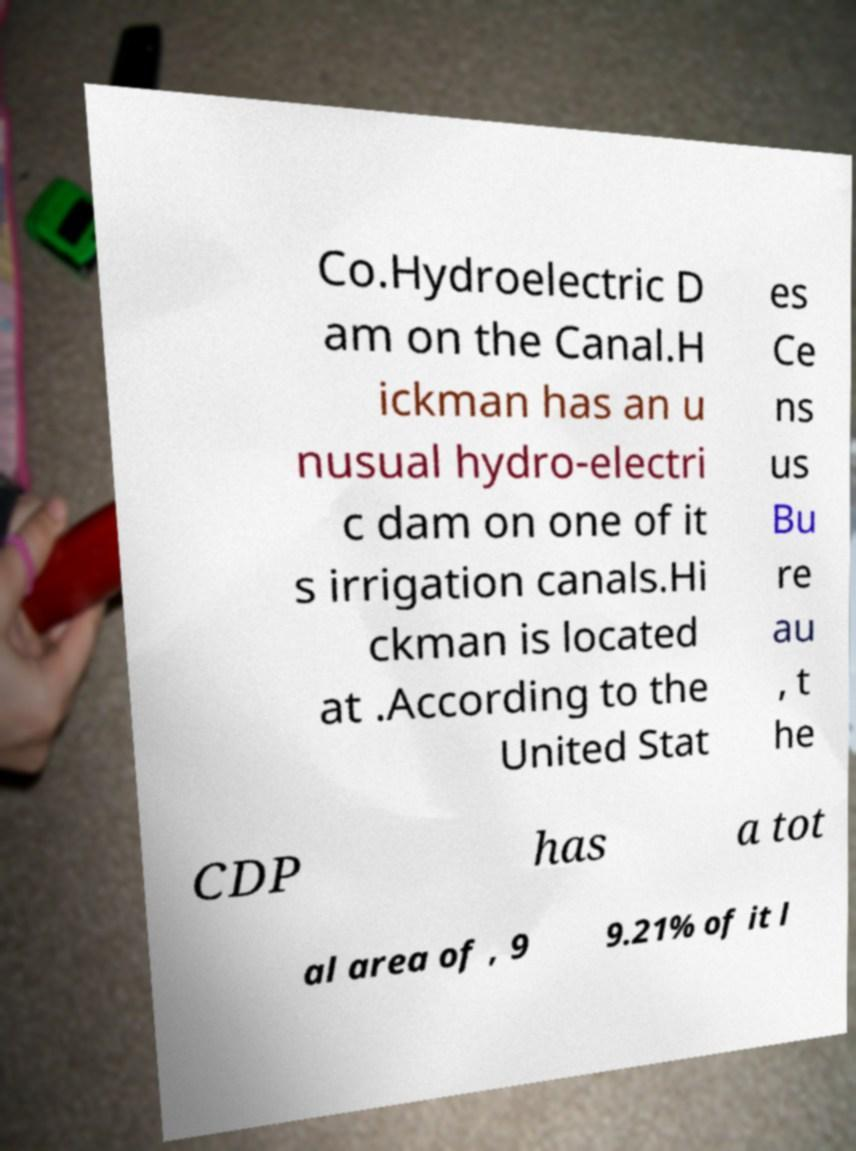Can you read and provide the text displayed in the image?This photo seems to have some interesting text. Can you extract and type it out for me? Co.Hydroelectric D am on the Canal.H ickman has an u nusual hydro-electri c dam on one of it s irrigation canals.Hi ckman is located at .According to the United Stat es Ce ns us Bu re au , t he CDP has a tot al area of , 9 9.21% of it l 